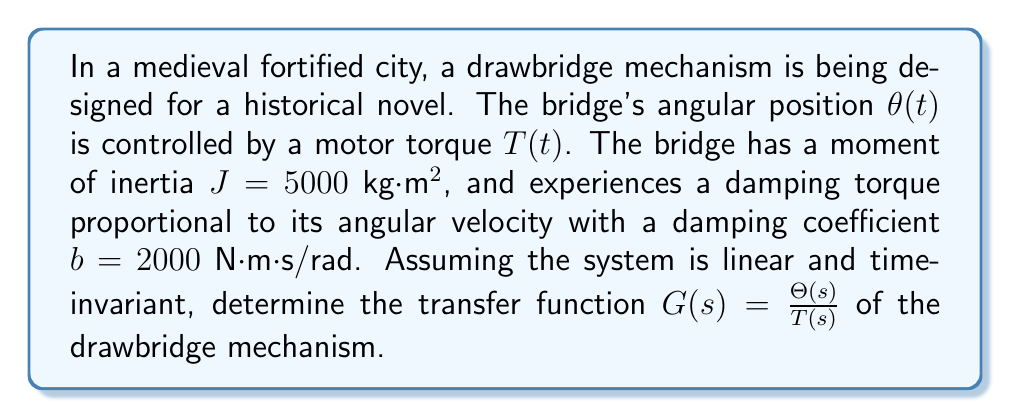Help me with this question. To determine the transfer function of the drawbridge mechanism, we'll follow these steps:

1) First, let's write the equation of motion for the system:

   $$J\frac{d^2\theta}{dt^2} + b\frac{d\theta}{dt} = T(t)$$

   Where $J$ is the moment of inertia, $b$ is the damping coefficient, $\theta$ is the angular position, and $T$ is the input torque.

2) Now, we'll take the Laplace transform of both sides of the equation, assuming zero initial conditions:

   $$J[s^2\Theta(s)] + b[s\Theta(s)] = T(s)$$

3) Factoring out $\Theta(s)$:

   $$\Theta(s)[Js^2 + bs] = T(s)$$

4) Rearranging to get the transfer function $G(s) = \frac{\Theta(s)}{T(s)}$:

   $$G(s) = \frac{\Theta(s)}{T(s)} = \frac{1}{Js^2 + bs}$$

5) Substituting the given values $J = 5000$ kg⋅m² and $b = 2000$ N⋅m⋅s/rad:

   $$G(s) = \frac{1}{5000s^2 + 2000s}$$

6) Simplifying:

   $$G(s) = \frac{1}{1000(5s^2 + 2s)}$$

   $$G(s) = \frac{0.001}{5s^2 + 2s}$$

This transfer function represents how the drawbridge's angular position $\Theta(s)$ responds to the input torque $T(s)$ in the Laplace domain.
Answer: $$G(s) = \frac{0.001}{5s^2 + 2s}$$ 